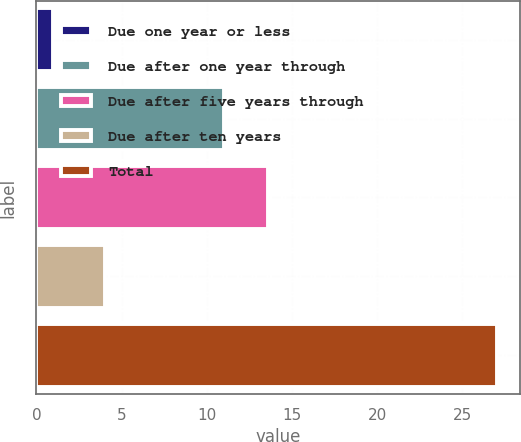Convert chart to OTSL. <chart><loc_0><loc_0><loc_500><loc_500><bar_chart><fcel>Due one year or less<fcel>Due after one year through<fcel>Due after five years through<fcel>Due after ten years<fcel>Total<nl><fcel>1<fcel>11<fcel>13.6<fcel>4<fcel>27<nl></chart> 